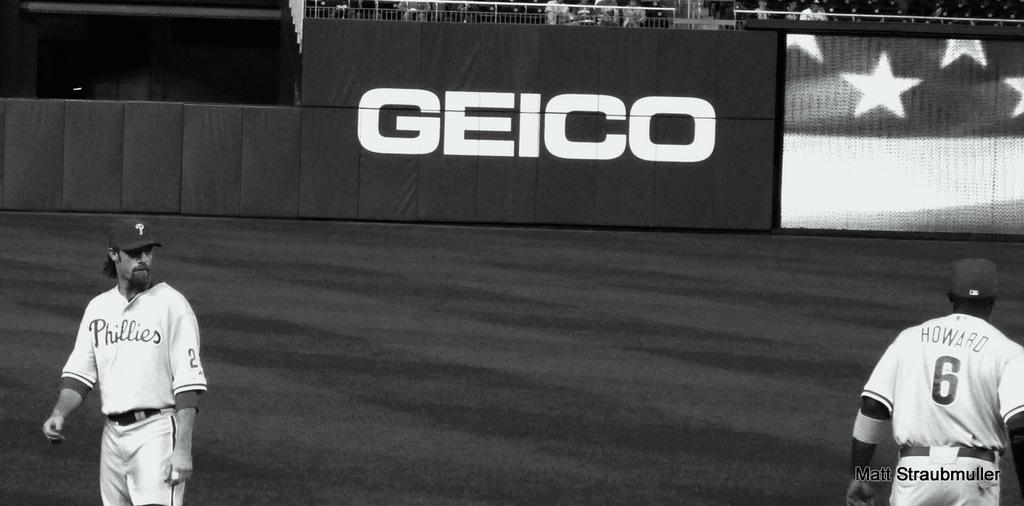<image>
Render a clear and concise summary of the photo. Two baseball players exchange glances, one with the number 6 on his back, and the other with the word "phillies" written across his chest. 